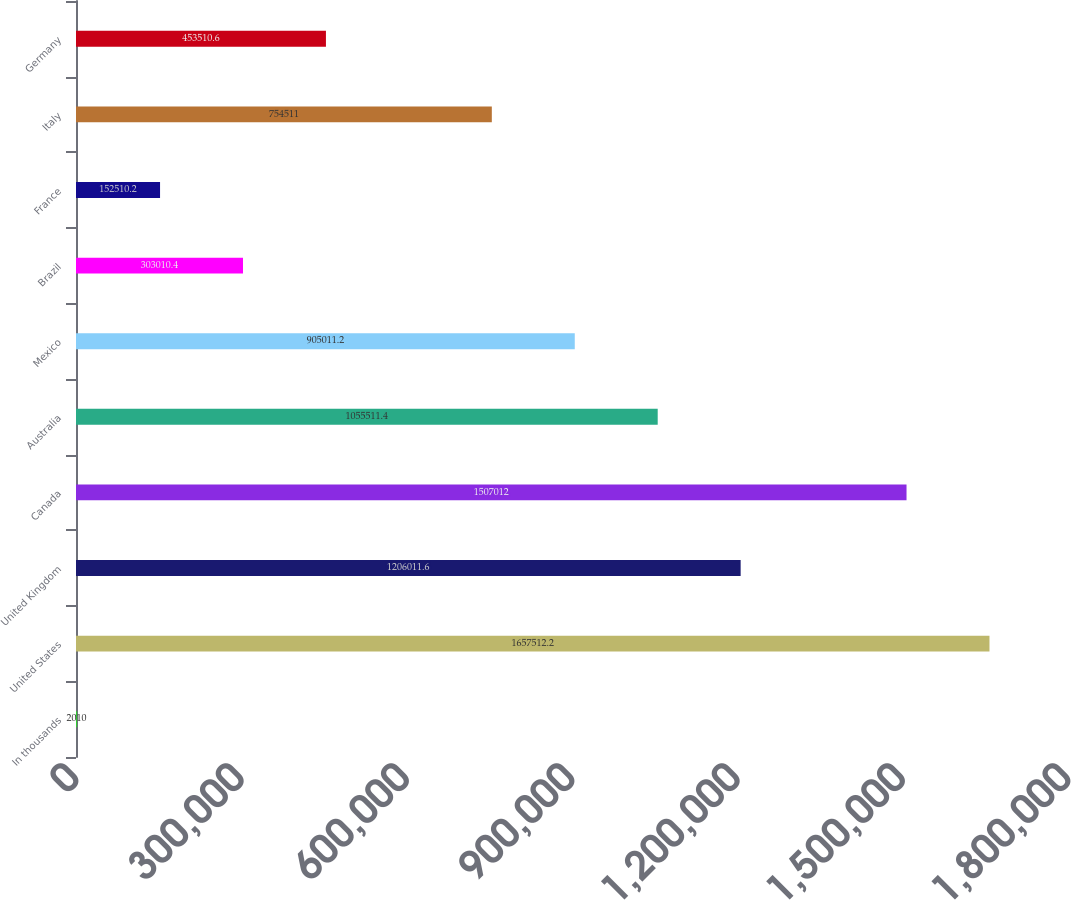<chart> <loc_0><loc_0><loc_500><loc_500><bar_chart><fcel>In thousands<fcel>United States<fcel>United Kingdom<fcel>Canada<fcel>Australia<fcel>Mexico<fcel>Brazil<fcel>France<fcel>Italy<fcel>Germany<nl><fcel>2010<fcel>1.65751e+06<fcel>1.20601e+06<fcel>1.50701e+06<fcel>1.05551e+06<fcel>905011<fcel>303010<fcel>152510<fcel>754511<fcel>453511<nl></chart> 